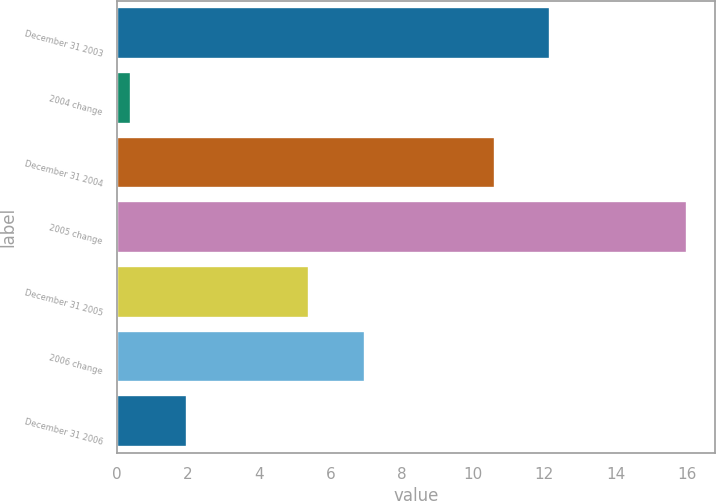Convert chart. <chart><loc_0><loc_0><loc_500><loc_500><bar_chart><fcel>December 31 2003<fcel>2004 change<fcel>December 31 2004<fcel>2005 change<fcel>December 31 2005<fcel>2006 change<fcel>December 31 2006<nl><fcel>12.16<fcel>0.4<fcel>10.6<fcel>16<fcel>5.4<fcel>6.96<fcel>1.96<nl></chart> 